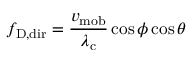<formula> <loc_0><loc_0><loc_500><loc_500>f _ { D , d i r } = { \frac { v _ { m o b } } { \lambda _ { c } } } \cos \phi \cos \theta</formula> 